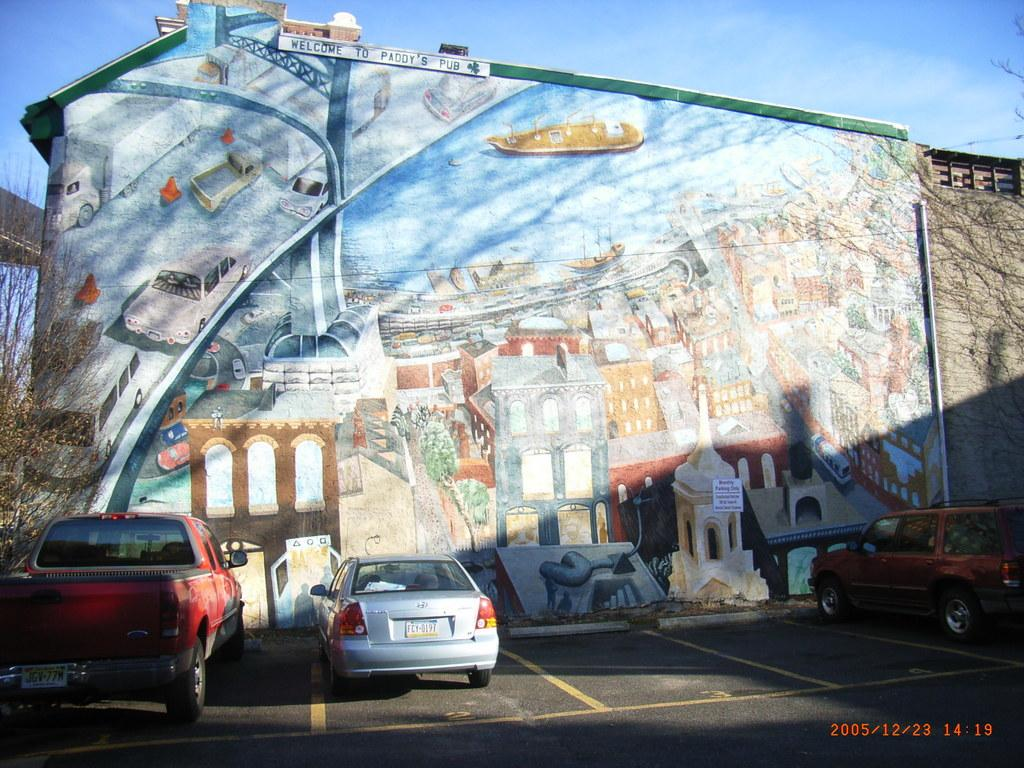What can be seen on the road in the image? There are vehicles on the road in the image. What type of natural elements are visible in the image? There are trees visible in the image. What is painted on the wall in the image? There is a wall with different images painted on it in the image. What is visible in the background of the image? The sky is visible in the background of the image. Can you describe the locket that is hanging from the tree in the image? There is no locket hanging from the tree in the image. What command is given to the vehicles on the road in the image? The image does not show any commands being given to the vehicles; it simply depicts them on the road. 